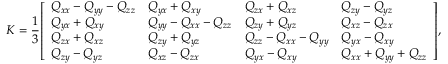Convert formula to latex. <formula><loc_0><loc_0><loc_500><loc_500>K = { \frac { 1 } { 3 } } { \left [ \begin{array} { l l l l } { Q _ { x x } - Q _ { y y } - Q _ { z z } } & { Q _ { y x } + Q _ { x y } } & { Q _ { z x } + Q _ { x z } } & { Q _ { z y } - Q _ { y z } } \\ { Q _ { y x } + Q _ { x y } } & { Q _ { y y } - Q _ { x x } - Q _ { z z } } & { Q _ { z y } + Q _ { y z } } & { Q _ { x z } - Q _ { z x } } \\ { Q _ { z x } + Q _ { x z } } & { Q _ { z y } + Q _ { y z } } & { Q _ { z z } - Q _ { x x } - Q _ { y y } } & { Q _ { y x } - Q _ { x y } } \\ { Q _ { z y } - Q _ { y z } } & { Q _ { x z } - Q _ { z x } } & { Q _ { y x } - Q _ { x y } } & { Q _ { x x } + Q _ { y y } + Q _ { z z } } \end{array} \right ] } ,</formula> 